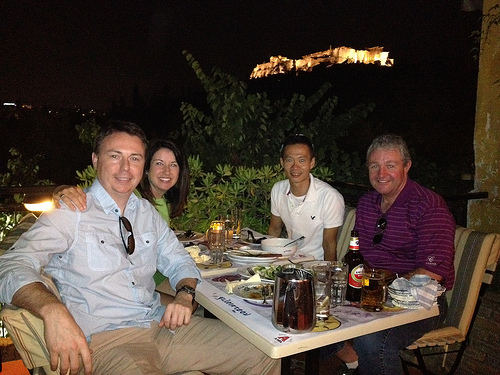What kind of setting are these people in? They are at an outdoor dining area, likely at a restaurant, with a view of illuminated ruins on a hill in the background. What might be the historical significance of the structure in the background? It seems to be an ancient fortress or ruins, which suggests they are in a place with a rich cultural or historical legacy. 